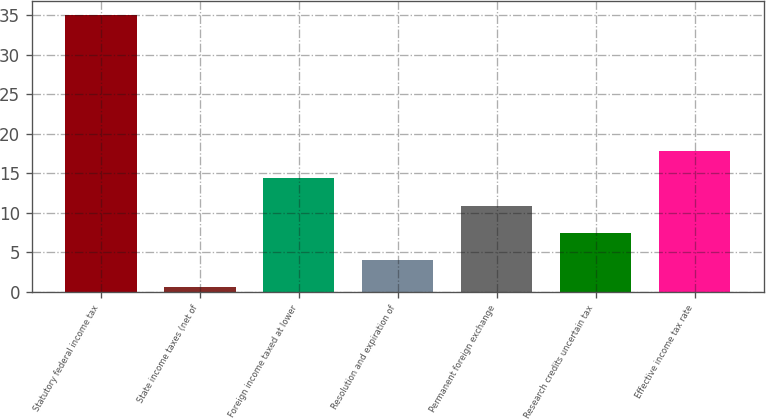Convert chart to OTSL. <chart><loc_0><loc_0><loc_500><loc_500><bar_chart><fcel>Statutory federal income tax<fcel>State income taxes (net of<fcel>Foreign income taxed at lower<fcel>Resolution and expiration of<fcel>Permanent foreign exchange<fcel>Research credits uncertain tax<fcel>Effective income tax rate<nl><fcel>35<fcel>0.6<fcel>14.36<fcel>4.04<fcel>10.92<fcel>7.48<fcel>17.8<nl></chart> 